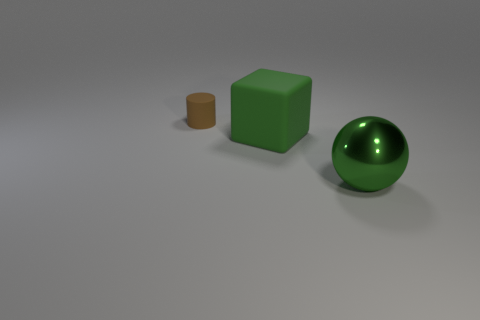What number of other brown objects are the same shape as the tiny brown object?
Ensure brevity in your answer.  0. There is a ball that is the same color as the large matte thing; what is its material?
Offer a very short reply. Metal. Are there any other things that are the same shape as the small rubber object?
Your response must be concise. No. What color is the matte object to the right of the rubber object that is on the left side of the large thing that is behind the green sphere?
Keep it short and to the point. Green. What number of large objects are either brown cylinders or cyan matte things?
Provide a short and direct response. 0. Are there an equal number of matte objects that are behind the small rubber cylinder and big red metallic blocks?
Make the answer very short. Yes. Are there any cubes in front of the green metal sphere?
Make the answer very short. No. What number of rubber things are big cyan spheres or tiny brown objects?
Provide a short and direct response. 1. How many matte cubes are to the right of the large shiny thing?
Your response must be concise. 0. Are there any yellow cylinders that have the same size as the block?
Make the answer very short. No. 